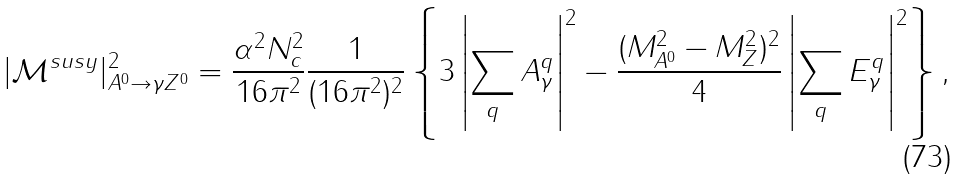Convert formula to latex. <formula><loc_0><loc_0><loc_500><loc_500>| \mathcal { M } ^ { s u s y } | ^ { 2 } _ { A ^ { 0 } \rightarrow \gamma Z ^ { 0 } } = \frac { \alpha ^ { 2 } N _ { c } ^ { 2 } } { 1 6 \pi ^ { 2 } } \frac { 1 } { ( 1 6 \pi ^ { 2 } ) ^ { 2 } } \left \{ 3 \left | \sum _ { q } A ^ { q } _ { \gamma } \right | ^ { 2 } - \frac { ( M _ { A ^ { 0 } } ^ { 2 } - M _ { Z } ^ { 2 } ) ^ { 2 } } { 4 } \left | \sum _ { q } E ^ { q } _ { \gamma } \right | ^ { 2 } \right \} ,</formula> 